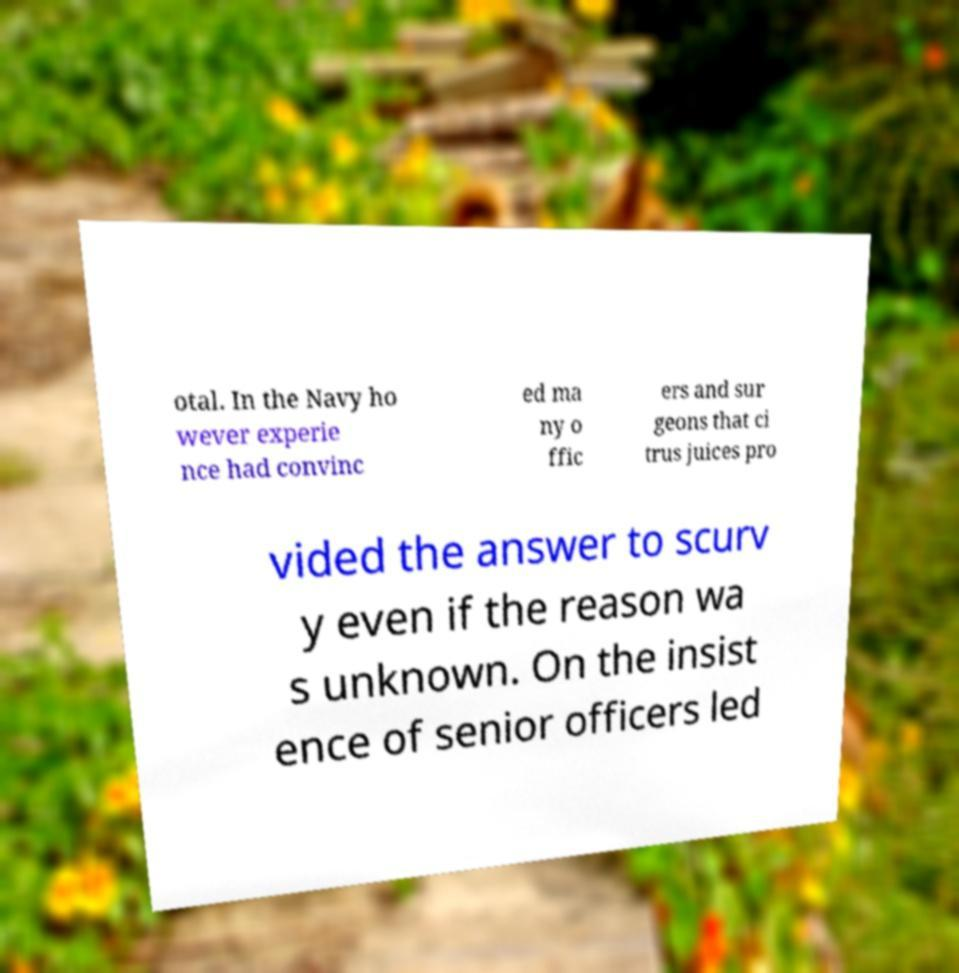Please read and relay the text visible in this image. What does it say? otal. In the Navy ho wever experie nce had convinc ed ma ny o ffic ers and sur geons that ci trus juices pro vided the answer to scurv y even if the reason wa s unknown. On the insist ence of senior officers led 